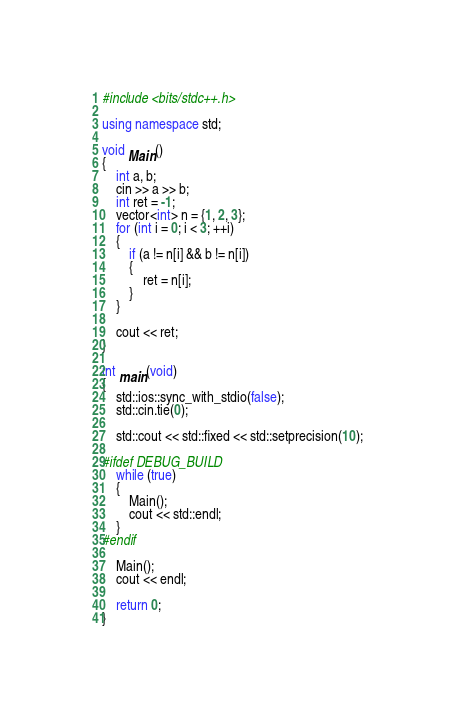<code> <loc_0><loc_0><loc_500><loc_500><_C++_>
#include <bits/stdc++.h>

using namespace std;

void Main()
{
    int a, b;
    cin >> a >> b;
    int ret = -1;
    vector<int> n = {1, 2, 3};
    for (int i = 0; i < 3; ++i)
    {
        if (a != n[i] && b != n[i])
        {
            ret = n[i];
        }
    }

    cout << ret;
}

int main(void)
{
    std::ios::sync_with_stdio(false);
    std::cin.tie(0);

    std::cout << std::fixed << std::setprecision(10);

#ifdef DEBUG_BUILD
    while (true)
    {
        Main();
        cout << std::endl;
    }
#endif

    Main();
    cout << endl;

    return 0;
}</code> 